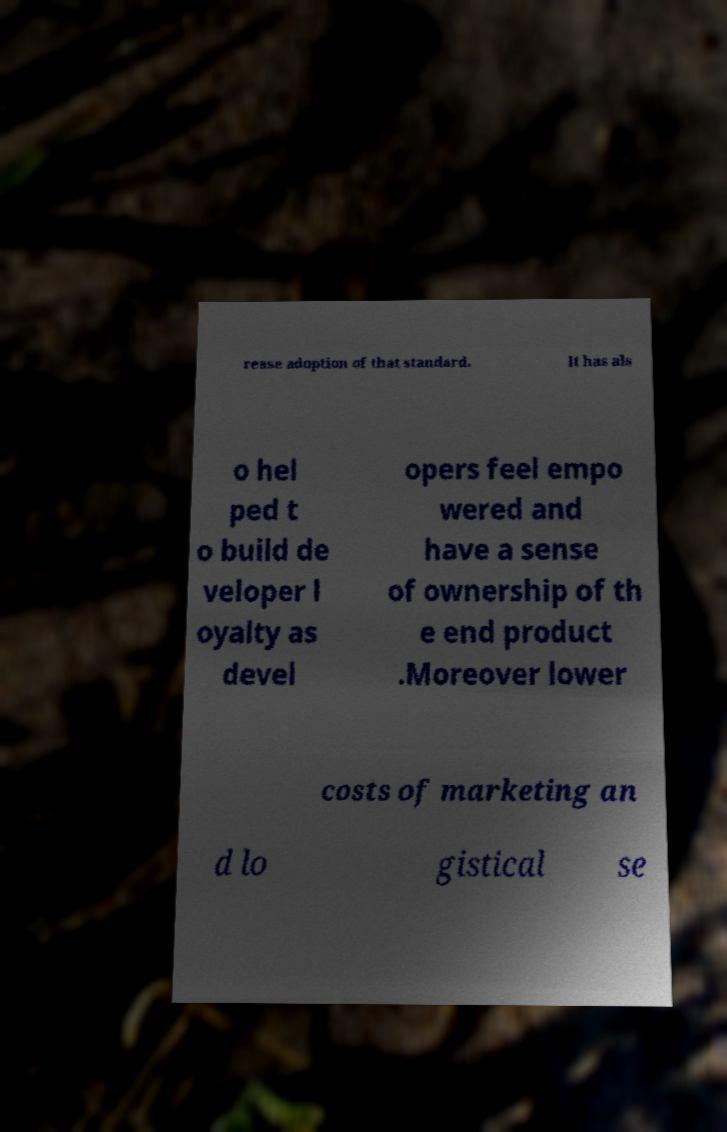I need the written content from this picture converted into text. Can you do that? rease adoption of that standard. It has als o hel ped t o build de veloper l oyalty as devel opers feel empo wered and have a sense of ownership of th e end product .Moreover lower costs of marketing an d lo gistical se 